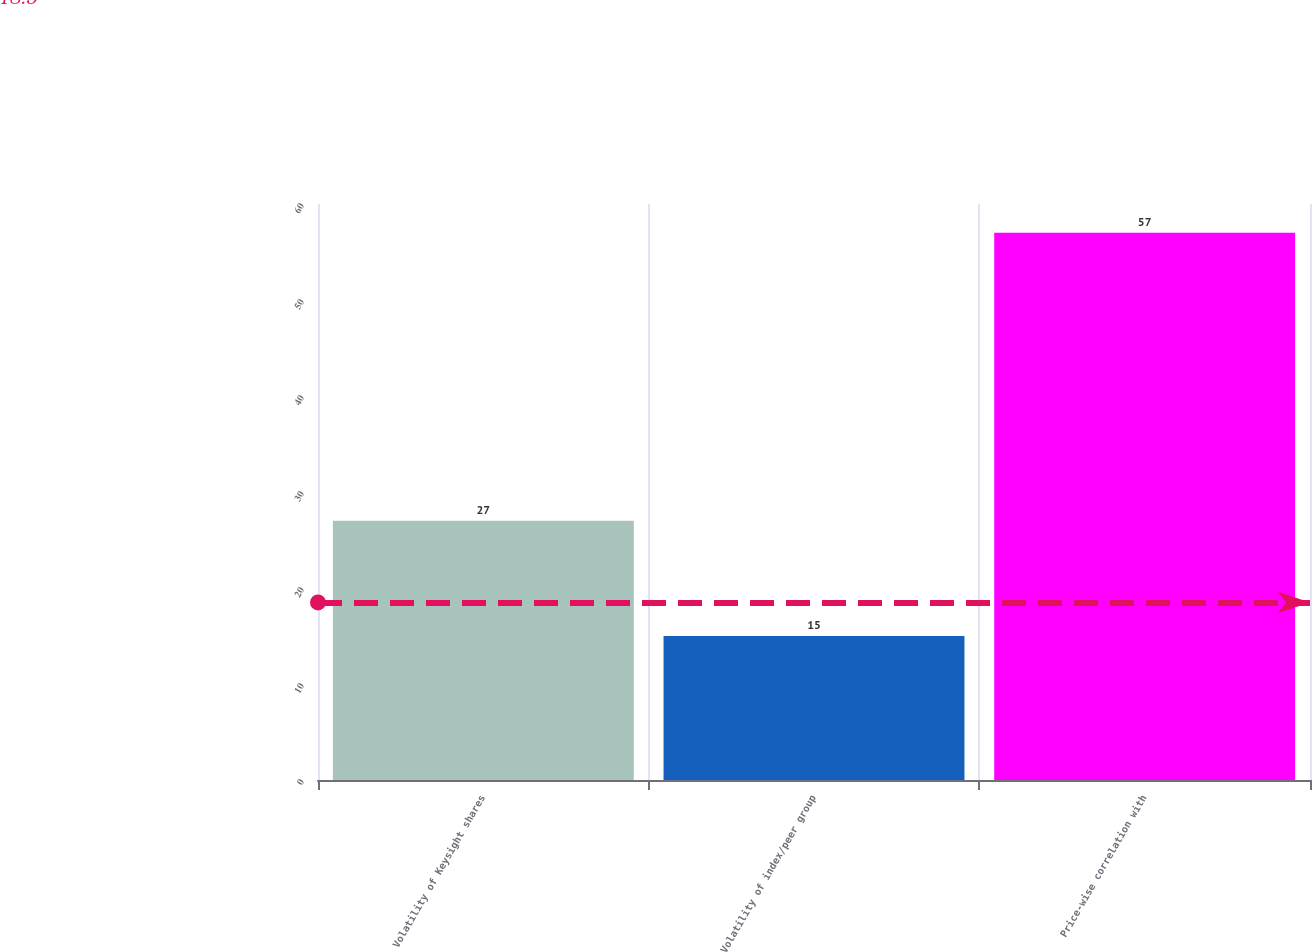Convert chart. <chart><loc_0><loc_0><loc_500><loc_500><bar_chart><fcel>Volatility of Keysight shares<fcel>Volatility of index/peer group<fcel>Price-wise correlation with<nl><fcel>27<fcel>15<fcel>57<nl></chart> 